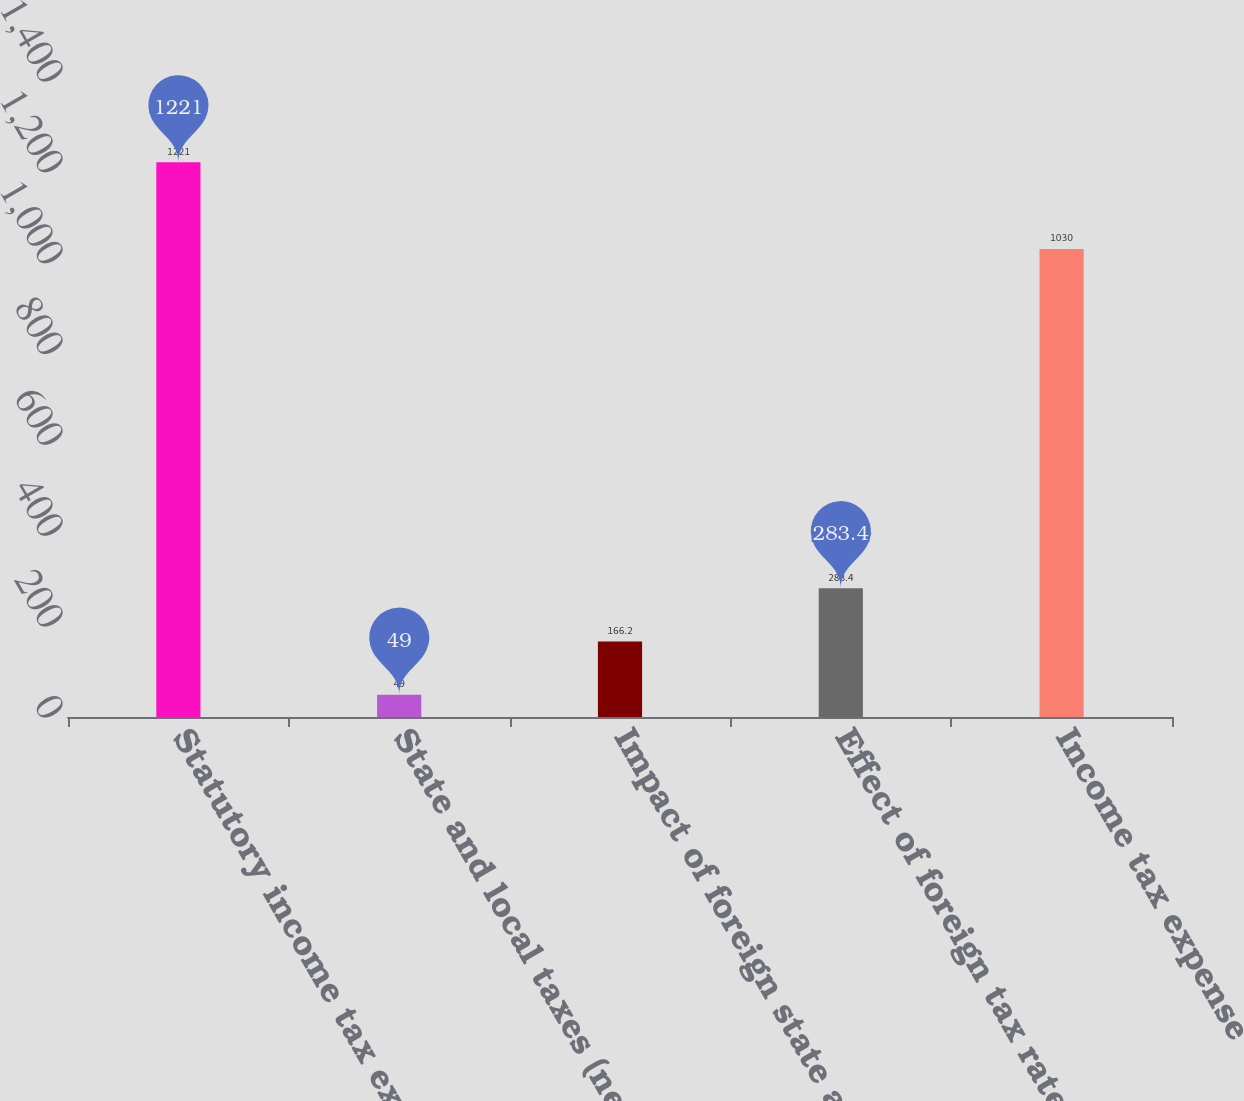Convert chart to OTSL. <chart><loc_0><loc_0><loc_500><loc_500><bar_chart><fcel>Statutory income tax expense<fcel>State and local taxes (net of<fcel>Impact of foreign state and<fcel>Effect of foreign tax rates<fcel>Income tax expense<nl><fcel>1221<fcel>49<fcel>166.2<fcel>283.4<fcel>1030<nl></chart> 